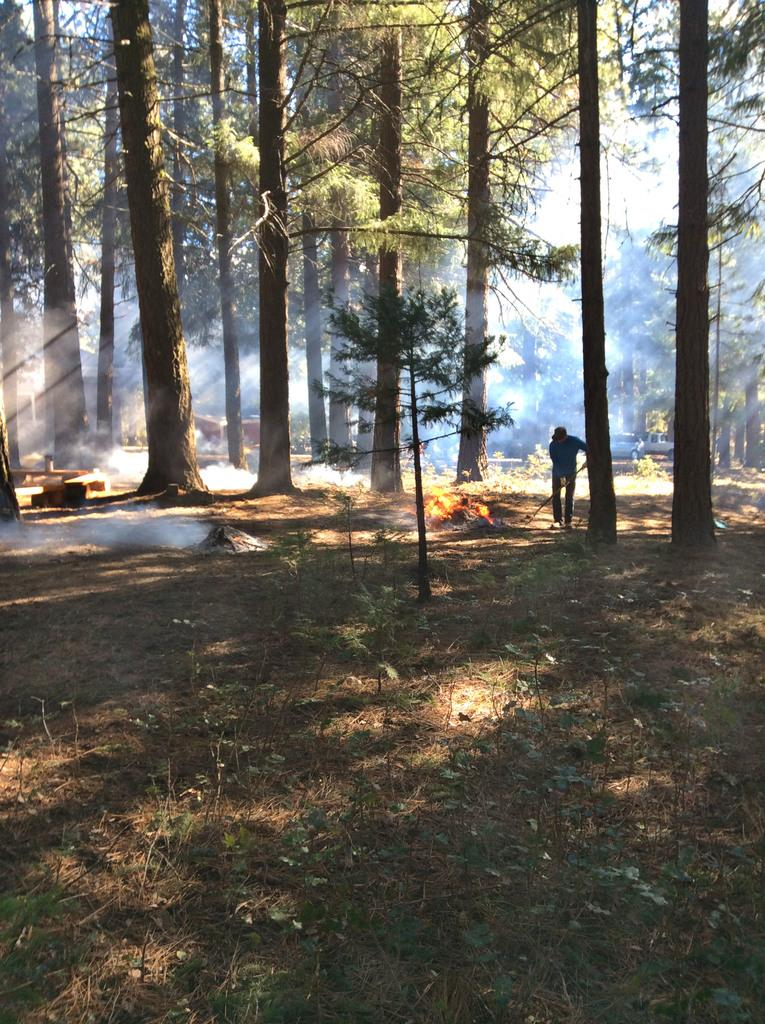What is the main subject of the image? There is a person standing in the image. What is the person holding in the image? The person is holding an object. What can be seen in the background of the image? There are trees and the sky visible in the background of the image. What is the color of the trees in the image? The trees are green in the image. What is the color of the sky in the image? The sky is white in color in the image. How many hens are sitting on the person's shoulder in the image? There are no hens present in the image. What type of debt is the person discussing with the trees in the background? There is no mention of debt or any discussion in the image. 